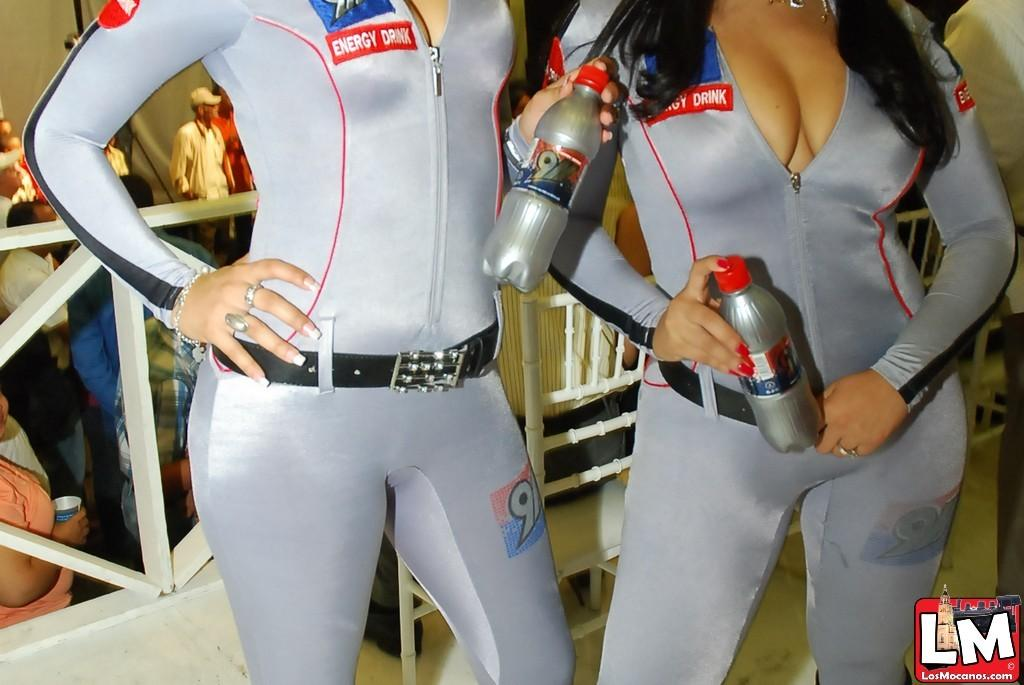Provide a one-sentence caption for the provided image. Two women in tight silver bodysuits promote an energy drink at an event. 